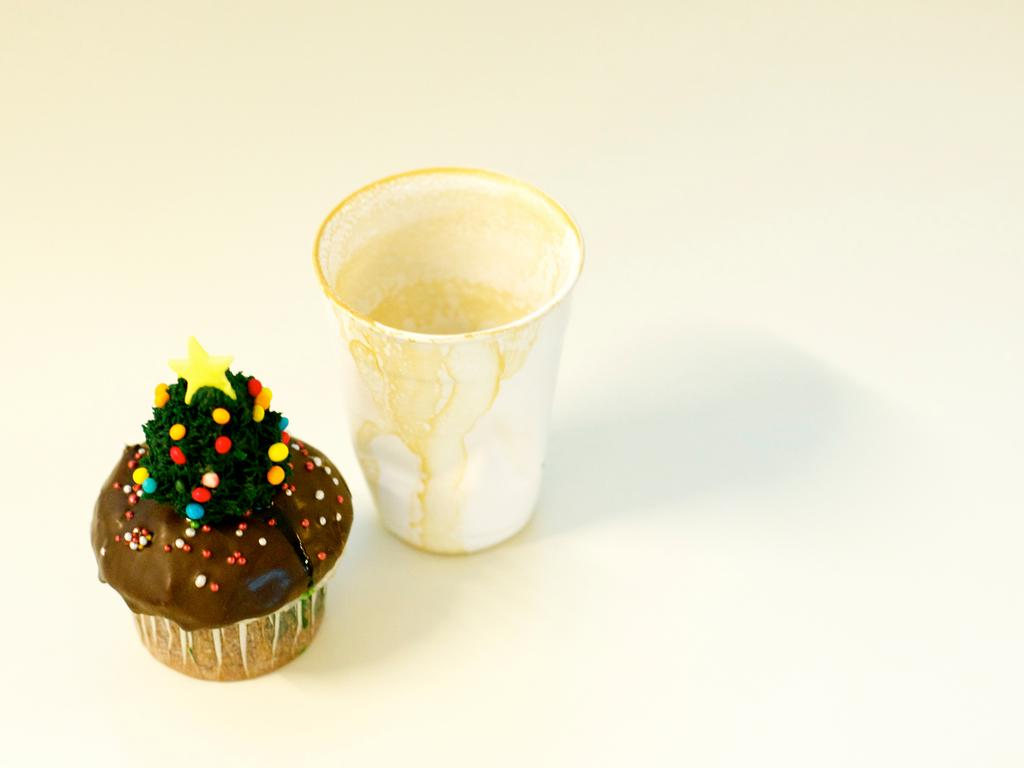What is one object visible in the image? There is a cup in the image. What is another object visible in the image? There is a cupcake in the image. What is the color of the surface the cup and cupcake are on? The surface the cup and cupcake are on is white. How many spiders are crawling on the cupcake in the image? There are no spiders present in the image; it only features a cup and a cupcake on a white surface. 